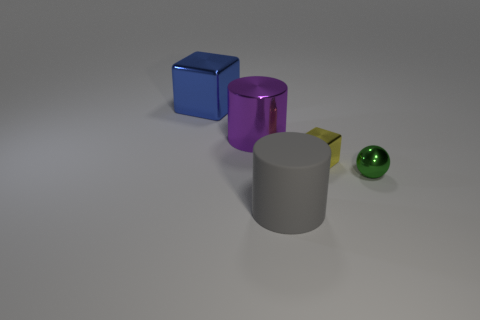Add 1 rubber objects. How many objects exist? 6 Subtract all spheres. How many objects are left? 4 Subtract 0 yellow balls. How many objects are left? 5 Subtract all cubes. Subtract all small things. How many objects are left? 1 Add 4 large blue objects. How many large blue objects are left? 5 Add 2 rubber cylinders. How many rubber cylinders exist? 3 